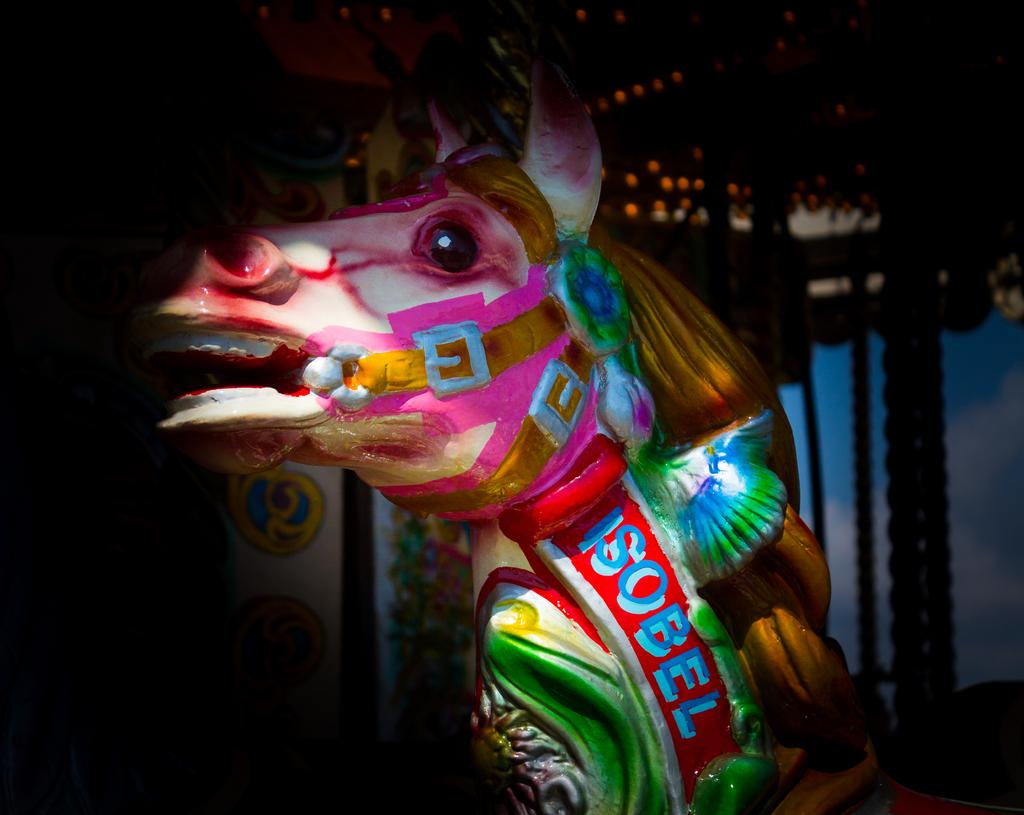What is the main subject of the image? There is a depiction of a horse in the image. Are there any words or letters in the image? Yes, there is text written in the image. How would you describe the overall color scheme of the image? The background of the image appears to be darker. How many cows are visible in the image? There are no cows present in the image; it features a depiction of a horse and text. What type of snack is being offered in the image? There is no snack, such as popcorn, present in the image. 